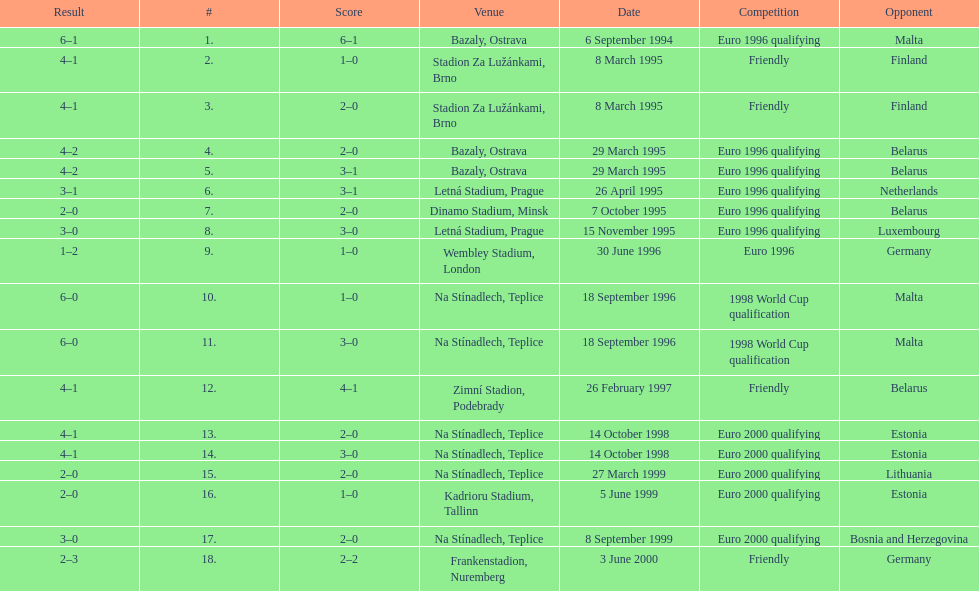How many total games took place in 1999? 3. 